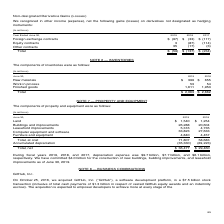According to Microsoft Corporation's financial document, What does note 7 describe? Property and equipment. The document states: "NOTE 7 — PROPERTY AND EQUIPMENT..." Also, How much was the depreciation expense for fiscal year 2017? According to the financial document, $6.1 billion. The relevant text states: "iation expense was $9.7 billion, $7.7 billion, and $6.1 billion, respectively. We have committed $4.0 billion for the construction of new buildings, building impro..." Also, How much has the company committed for the construction of new buildings, building improvements, and leasehold improvements? According to the financial document, $4.0 billion. The relevant text states: "and $6.1 billion, respectively. We have committed $4.0 billion for the construction of new buildings, building improvements, and leasehold improvements as of June..." Also, How many components of property and equipment are there? Counting the relevant items in the document: Lease, buildings and improvements, leasehold improvements, computer equipment and software, furniture and equipment, I find 5 instances. The key data points involved are: Lease, buildings and improvements, computer equipment and software. Also, can you calculate: How much was the average depreciation expense over the 3 year period from 2017 to 2019? To answer this question, I need to perform calculations using the financial data. The calculation is: ($9.7+7.7+6.1)/(2019-2017+1), which equals 7.83 (in billions). This is based on the information: "tion expense was $9.7 billion, $7.7 billion, and $6.1 billion, respectively. We have committed $4.0 billion for the construction of new buildings, buildi and 2017, depreciation expense was $9.7 billio..." The key data points involved are: 6.1, 7.7, 9.7. Also, can you calculate: How much were the top 3 components of property and equipment as a % of the total at cost, property and equipment for 2019? To answer this question, I need to perform calculations using the financial data. The calculation is: (26,288+33,823+5,316)/71,807, which equals 91.12 (percentage). This is based on the information: "Total, at cost 71,807 58,683 Buildings and improvements 26,288 20,604 Computer equipment and software 33,823 27,633 Leasehold improvements 5,316 4,735..." The key data points involved are: 26,288, 33,823, 5,316. 